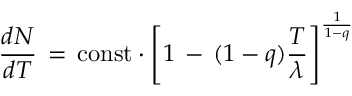<formula> <loc_0><loc_0><loc_500><loc_500>\frac { d N } { d T } \, = \, c o n s t \cdot \left [ 1 \, - \, ( 1 - q ) \frac { T } { \lambda } \right ] ^ { \frac { 1 } { 1 - q } }</formula> 